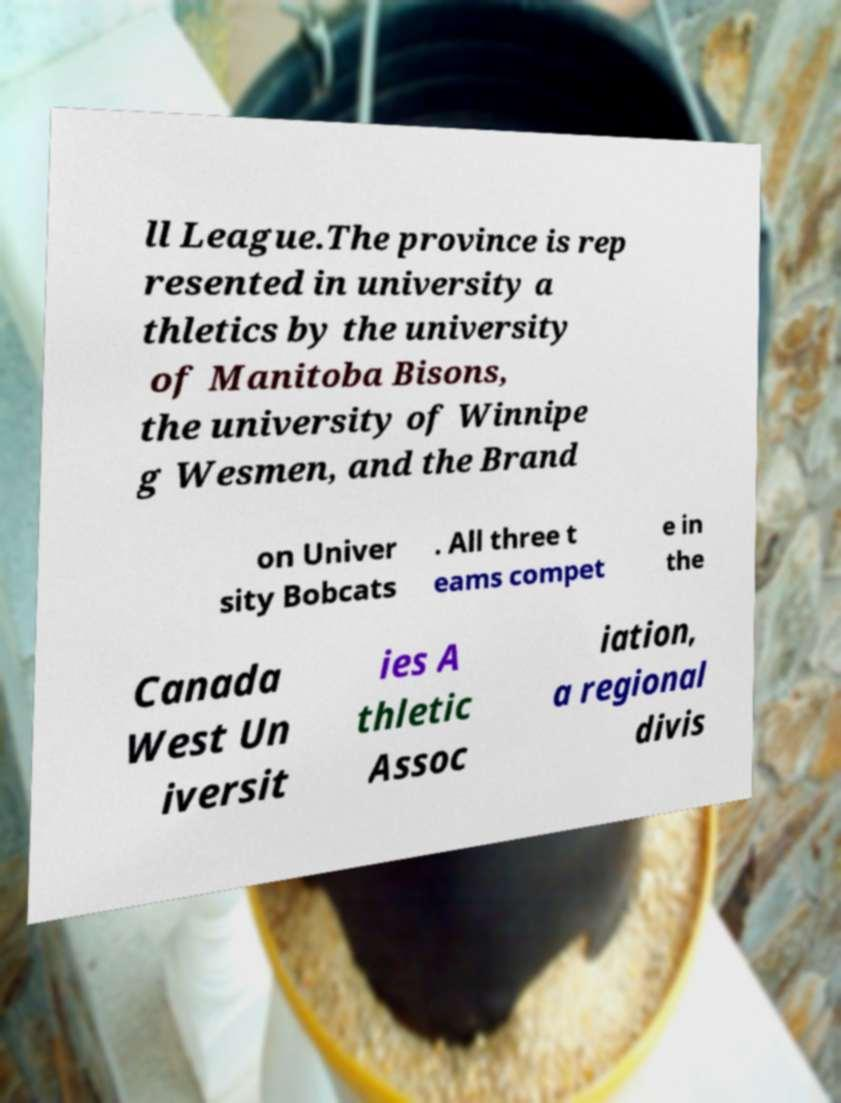For documentation purposes, I need the text within this image transcribed. Could you provide that? ll League.The province is rep resented in university a thletics by the university of Manitoba Bisons, the university of Winnipe g Wesmen, and the Brand on Univer sity Bobcats . All three t eams compet e in the Canada West Un iversit ies A thletic Assoc iation, a regional divis 